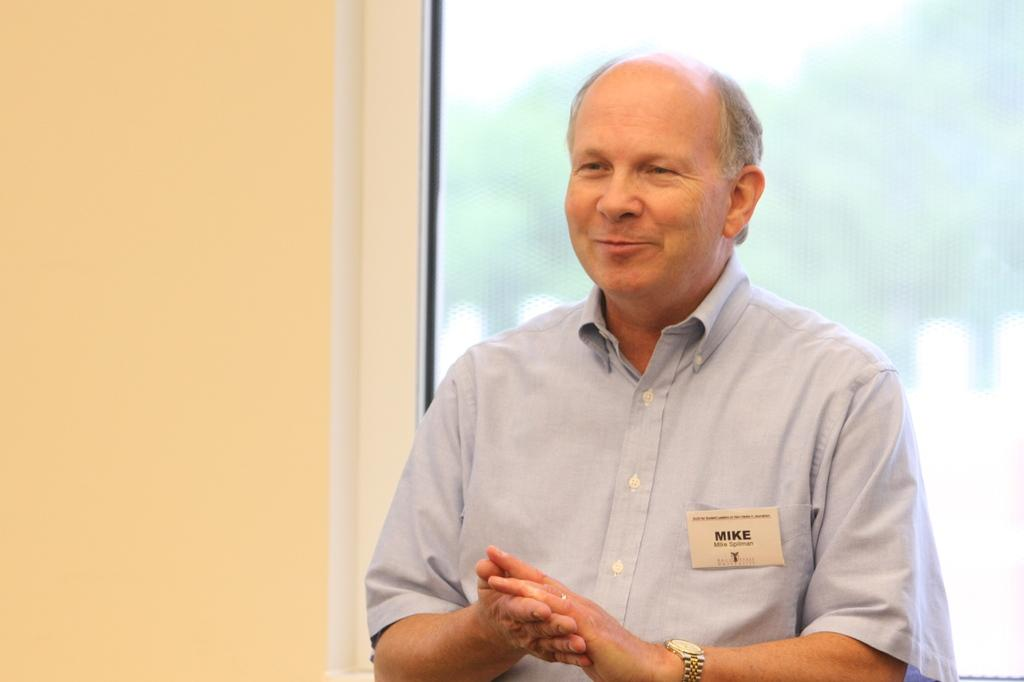What is the main subject of the image? There is a person in the image. Can you describe any details about the person? The person has a card on their pocket with some text on it. What can be seen in the background of the image? There is a wall and a window in the image. How many pizzas are being served on the table in the image? There is no table or pizzas present in the image. What type of quiver is the person holding in the image? There is no quiver present in the image. 